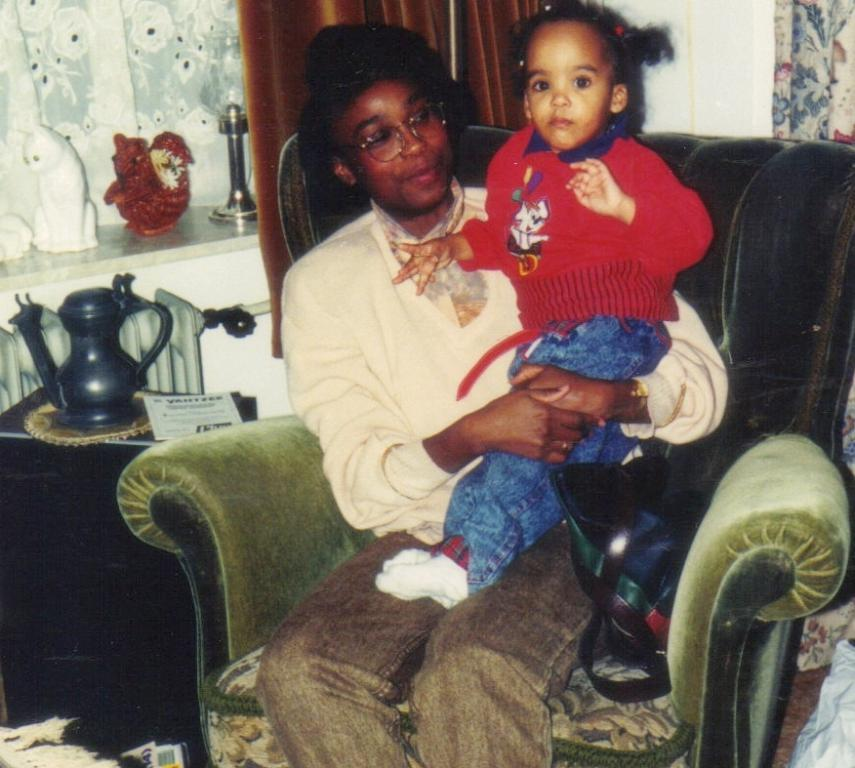Who is present in the image? There is a person and a child in the image. What are the person and child doing in the image? The person and child are sitting on a chair. What objects can be seen on the table in the image? There is a jar and a paper on the table. What type of feast is being prepared on the table in the image? There is no indication of a feast or any food preparation in the image. The table only contains a jar and a paper. 